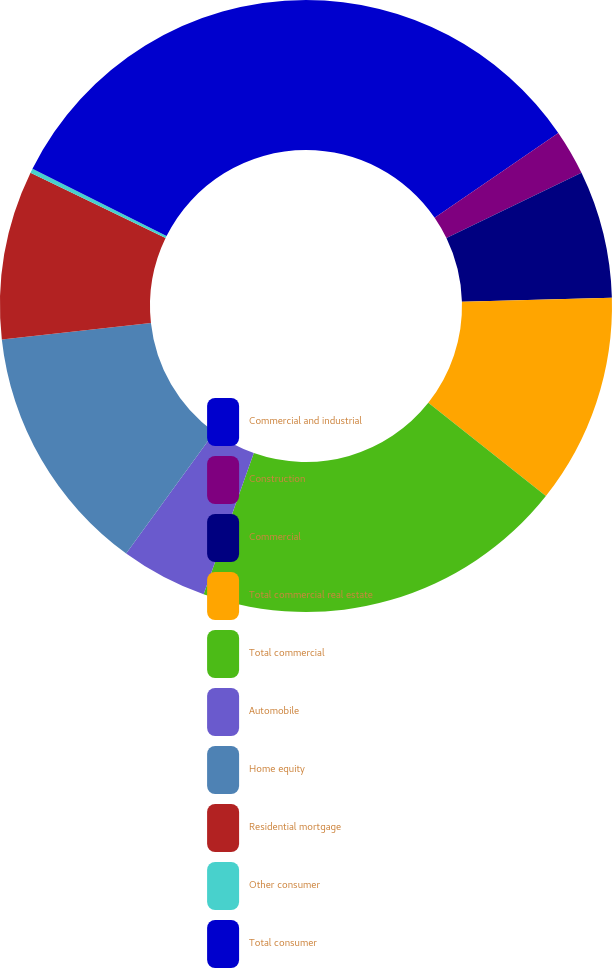Convert chart. <chart><loc_0><loc_0><loc_500><loc_500><pie_chart><fcel>Commercial and industrial<fcel>Construction<fcel>Commercial<fcel>Total commercial real estate<fcel>Total commercial<fcel>Automobile<fcel>Home equity<fcel>Residential mortgage<fcel>Other consumer<fcel>Total consumer<nl><fcel>15.43%<fcel>2.4%<fcel>6.74%<fcel>11.09%<fcel>19.77%<fcel>4.57%<fcel>13.26%<fcel>8.91%<fcel>0.23%<fcel>17.6%<nl></chart> 